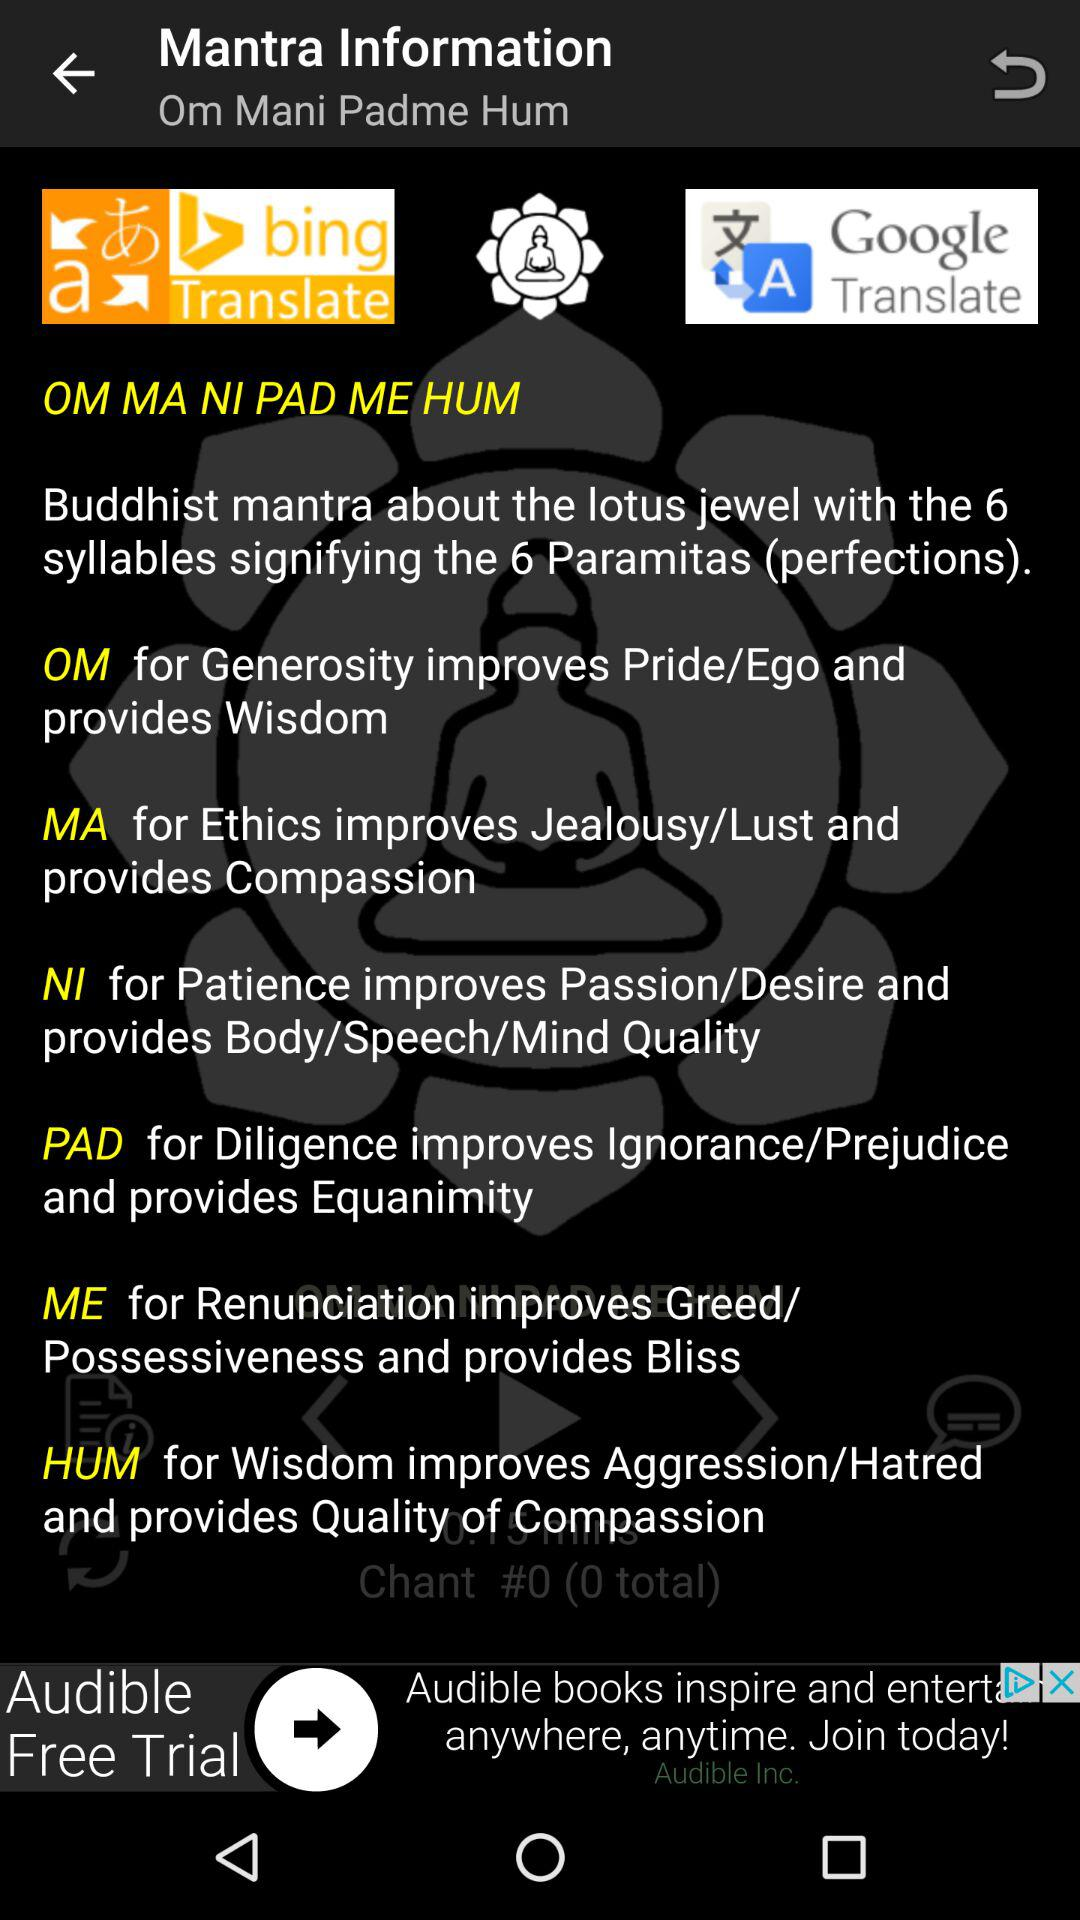What is the title of the post? The title is "Om Mani Padme Hum". 